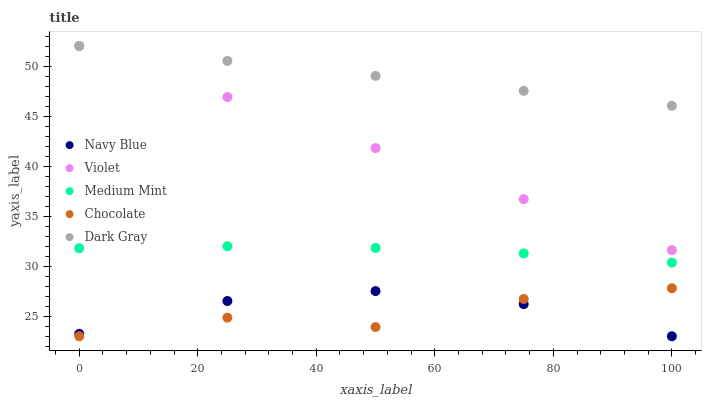Does Chocolate have the minimum area under the curve?
Answer yes or no. Yes. Does Dark Gray have the maximum area under the curve?
Answer yes or no. Yes. Does Navy Blue have the minimum area under the curve?
Answer yes or no. No. Does Navy Blue have the maximum area under the curve?
Answer yes or no. No. Is Dark Gray the smoothest?
Answer yes or no. Yes. Is Chocolate the roughest?
Answer yes or no. Yes. Is Navy Blue the smoothest?
Answer yes or no. No. Is Navy Blue the roughest?
Answer yes or no. No. Does Navy Blue have the lowest value?
Answer yes or no. Yes. Does Dark Gray have the lowest value?
Answer yes or no. No. Does Violet have the highest value?
Answer yes or no. Yes. Does Chocolate have the highest value?
Answer yes or no. No. Is Navy Blue less than Dark Gray?
Answer yes or no. Yes. Is Dark Gray greater than Navy Blue?
Answer yes or no. Yes. Does Navy Blue intersect Chocolate?
Answer yes or no. Yes. Is Navy Blue less than Chocolate?
Answer yes or no. No. Is Navy Blue greater than Chocolate?
Answer yes or no. No. Does Navy Blue intersect Dark Gray?
Answer yes or no. No. 